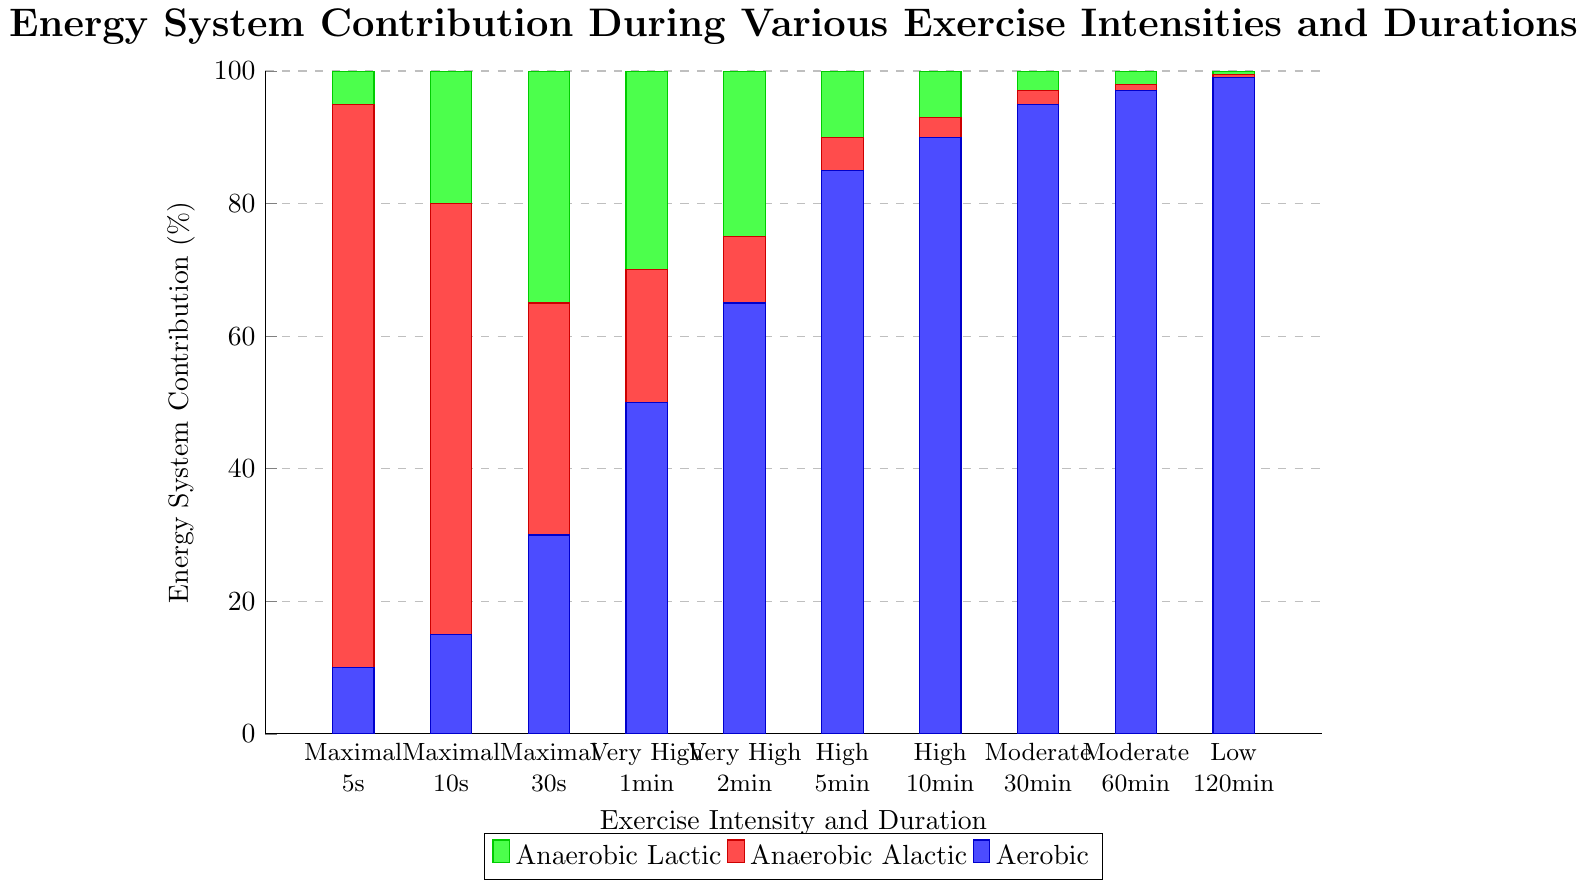What is the primary energy system contribution for a 30-second maximal exercise? The stacked bar for 30-second maximal exercise comprises blue (aerobic), red (anaerobic alactic), and green (anaerobic lactic) sections. The tallest section, red, represents the anaerobic alactic system.
Answer: Anaerobic Alactic Which exercise intensity and duration has the highest aerobic contribution? By examining all the bars, the tallest blue section, indicative of the aerobic contribution, is during the low intensity with a duration of 120 minutes.
Answer: Low, 120 minutes How does the anaerobic lactic contribution compare between 1-minute and 2-minute very high-intensity exercises? The 1-minute very high-intensity bar has a green section at 30%, while the 2-minute very high-intensity bar has a green section at 25%. The anaerobic lactic contribution is reduced by 5%.
Answer: It decreases by 5% What is the combined anaerobic alactic and anaerobic lactic contribution for a 10-minute high-intensity exercise? For the 10-minute high-intensity bar, the red section is at 3% and the green section is at 7%. Combined, the anaerobic contribution is 3% + 7% = 10%.
Answer: 10% What trend can be observed in aerobic contributions as exercise duration increases from 5 seconds to 120 minutes? Observing the bars from 5 seconds to 120 minutes, the blue sections representing aerobic contributions start low at 10% and progressively increase, peaking at 99% for the 120-minute low-intensity exercise.
Answer: Increasing trend Compare the anaerobic alactic contributions in maximal exercises between 5 seconds and 10 seconds. In the 5-second maximal category, the red section is at 85%, and in the 10-second maximal category, it is 65%. The anaerobic alactic contribution decreases by 20%.
Answer: Decreases by 20% How does aerobic contribution change between 30-minute and 60-minute moderate intensity exercises? The blue sections in the moderate intensity bars show a rise from 95% for 30 minutes to 97% for 60 minutes, an increase of 2%.
Answer: Increase by 2% What is the relationship between exercise intensity and the percentage of anaerobic alactic contribution? As exercise intensity decreases from maximal to low, the percentage of the red section (anaerobic alactic contribution) consistently decreases, reaching its minimum at low intensity.
Answer: Decreasing trend What's the difference in anaerobic lactic contribution between 30-second maximal and 5-minute high-intensity exercise? The 30-second maximal bar has a green section at 35%, while the 5-minute high-intensity bar has a green section at 10%. The difference is 35% - 10% = 25%.
Answer: 25% 